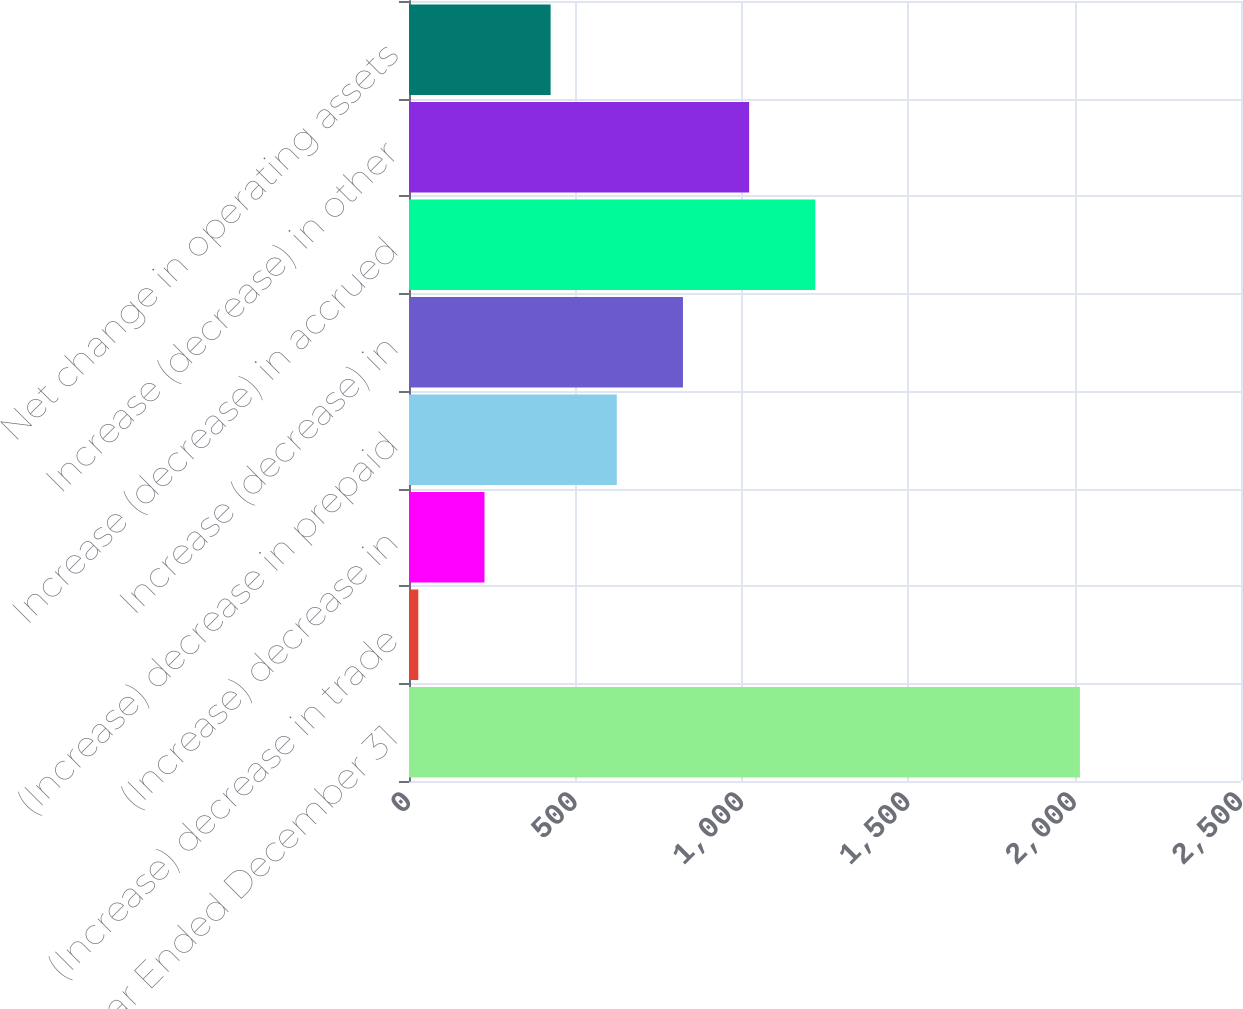Convert chart to OTSL. <chart><loc_0><loc_0><loc_500><loc_500><bar_chart><fcel>Year Ended December 31<fcel>(Increase) decrease in trade<fcel>(Increase) decrease in<fcel>(Increase) decrease in prepaid<fcel>Increase (decrease) in<fcel>Increase (decrease) in accrued<fcel>Increase (decrease) in other<fcel>Net change in operating assets<nl><fcel>2016<fcel>28<fcel>226.8<fcel>624.4<fcel>823.2<fcel>1220.8<fcel>1022<fcel>425.6<nl></chart> 